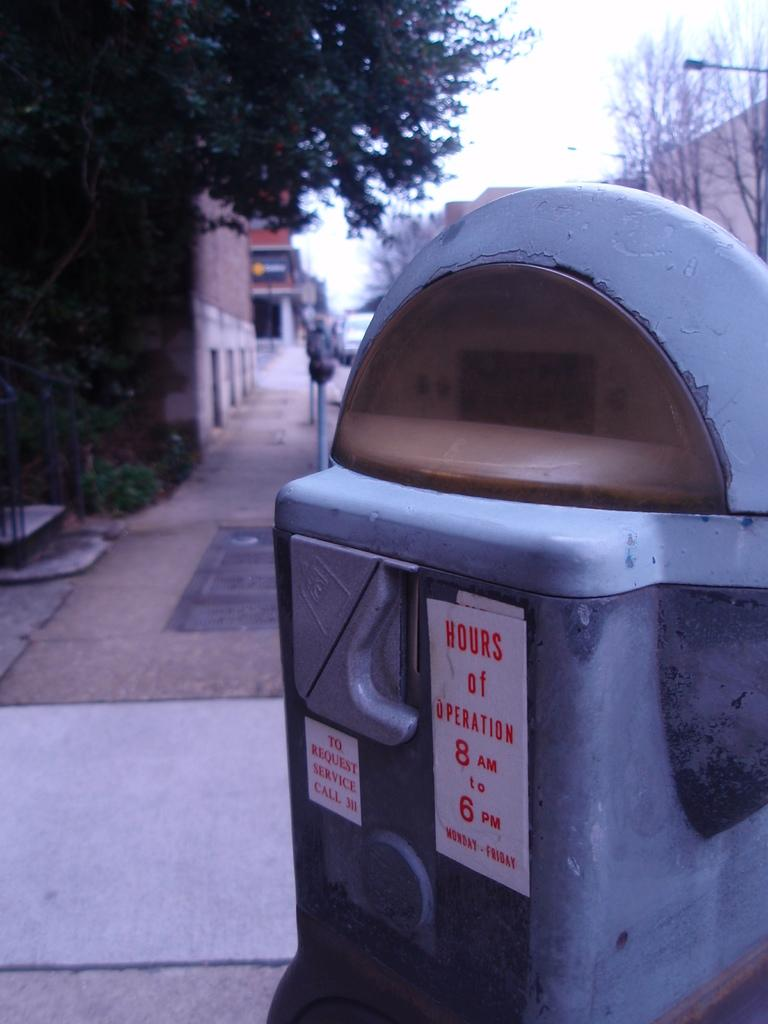Provide a one-sentence caption for the provided image. A parking meter showing hours of operation are from 8am to 6pm. 